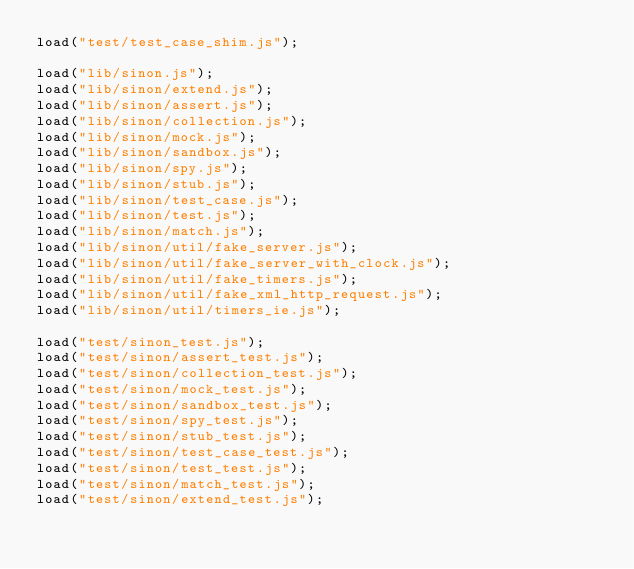Convert code to text. <code><loc_0><loc_0><loc_500><loc_500><_JavaScript_>load("test/test_case_shim.js");

load("lib/sinon.js");
load("lib/sinon/extend.js");
load("lib/sinon/assert.js");
load("lib/sinon/collection.js");
load("lib/sinon/mock.js");
load("lib/sinon/sandbox.js");
load("lib/sinon/spy.js");
load("lib/sinon/stub.js");
load("lib/sinon/test_case.js");
load("lib/sinon/test.js");
load("lib/sinon/match.js");
load("lib/sinon/util/fake_server.js");
load("lib/sinon/util/fake_server_with_clock.js");
load("lib/sinon/util/fake_timers.js");
load("lib/sinon/util/fake_xml_http_request.js");
load("lib/sinon/util/timers_ie.js");

load("test/sinon_test.js");
load("test/sinon/assert_test.js");
load("test/sinon/collection_test.js");
load("test/sinon/mock_test.js");
load("test/sinon/sandbox_test.js");
load("test/sinon/spy_test.js");
load("test/sinon/stub_test.js");
load("test/sinon/test_case_test.js");
load("test/sinon/test_test.js");
load("test/sinon/match_test.js");
load("test/sinon/extend_test.js");</code> 